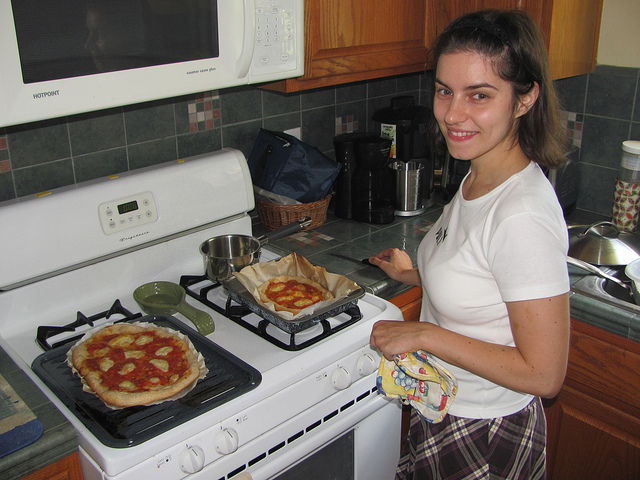<image>What is the woman's name? It is unknown what the woman's name is. What is the woman's name? I don't know the woman's name. It could be Lisa, Mom, Cynthia, Betty, Carla, Susan, Karen, Annie, Amber, or unknown. 